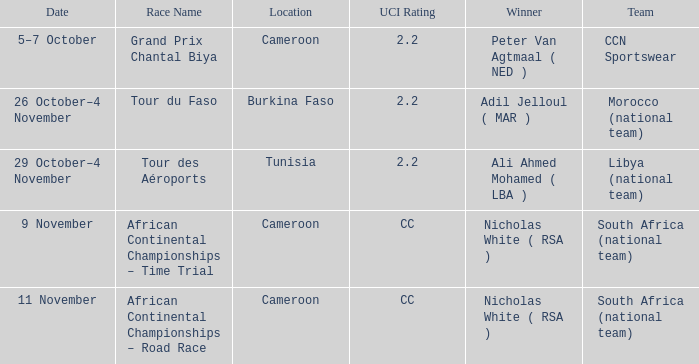Who emerged victorious in the burkina faso race? Adil Jelloul ( MAR ). 